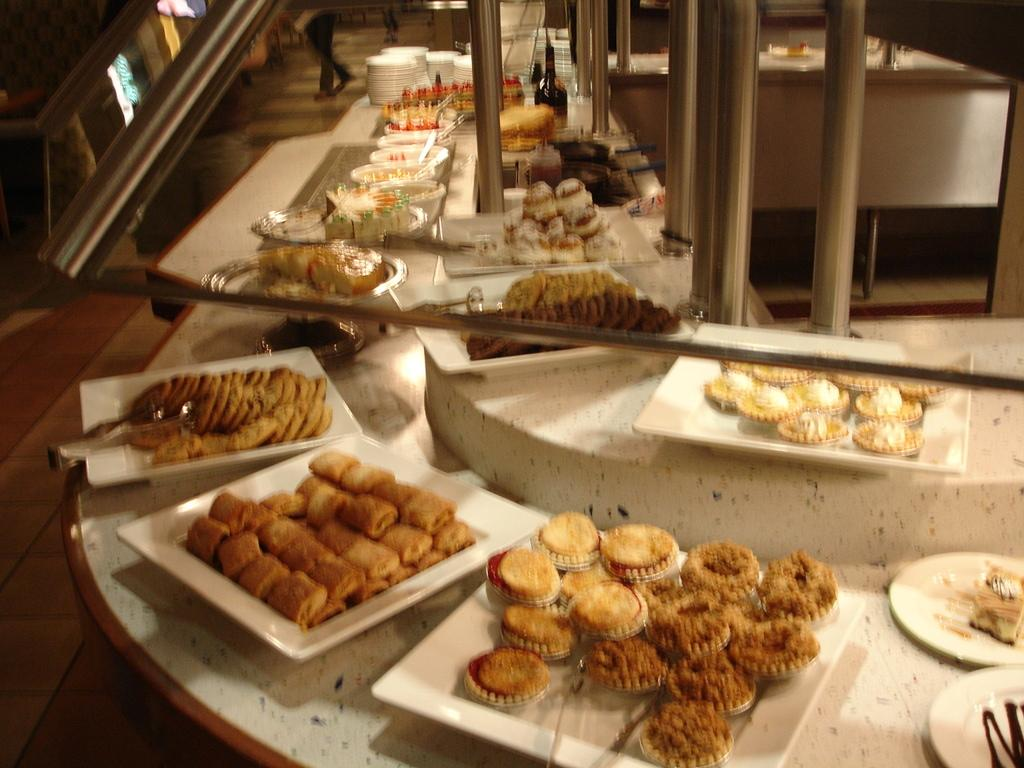What type of living organisms can be seen in the image? Plants can be seen in the image. What objects are on the table in the image? There are bowls on a table in the image. What is inside the bowls? The bowls contain food. What architectural features are visible at the top of the image? There are pillars visible at the top of the image. What educational institution is suggested by the presence of the plants in the image? There is no educational institution suggested by the presence of the plants in the image. 